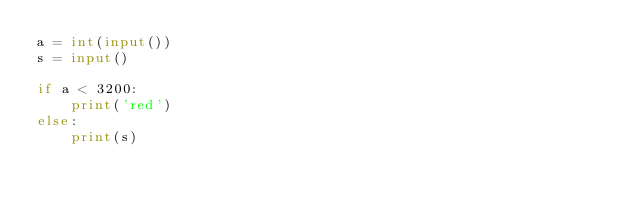Convert code to text. <code><loc_0><loc_0><loc_500><loc_500><_Python_>a = int(input())
s = input()

if a < 3200:
	print('red')
else:
	print(s)
	
</code> 